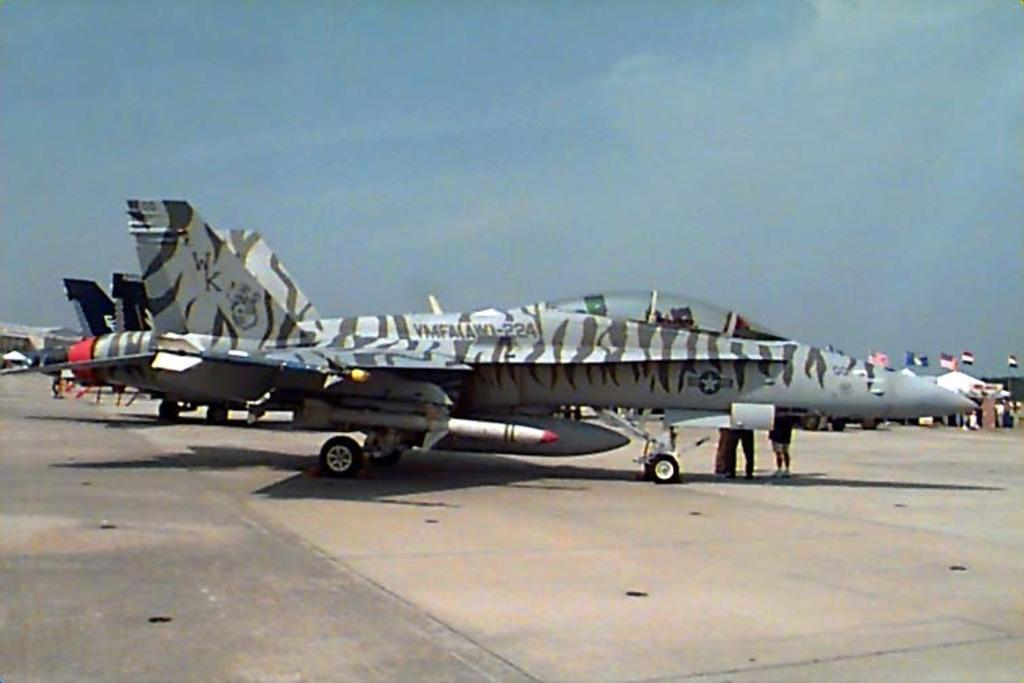What is unusual about the scene in the image? Airplanes are on the road, which is not a typical location for them. What else can be seen in the image besides the airplanes? There are flags and people in the image. What is visible in the background of the image? The sky is visible in the background of the image. What type of stamp can be seen on the airplanes in the image? There is no stamp visible on the airplanes in the image. What emotion are the people in the image experiencing? The image does not provide enough information to determine the emotions of the people in the image. 